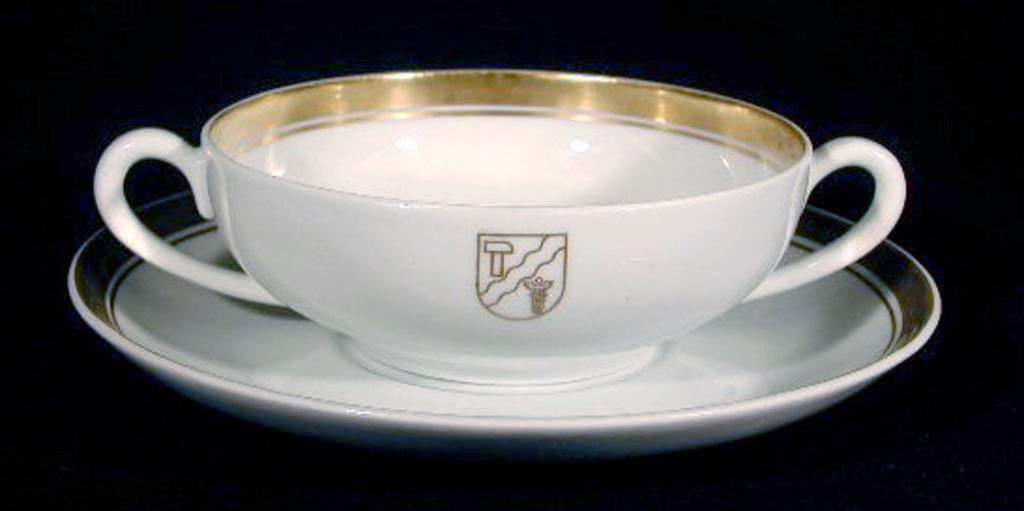What is present in the image that can hold a liquid? There is a cup in the image that can hold a liquid. Is the cup placed on any surface? Yes, the cup is in a saucer. What color are the cup and saucer? Both the cup and saucer are white in color. How many loaves of bread are visible in the image? There are no loaves of bread present in the image. What type of sugar is being used in the image? There is no sugar present in the image. 